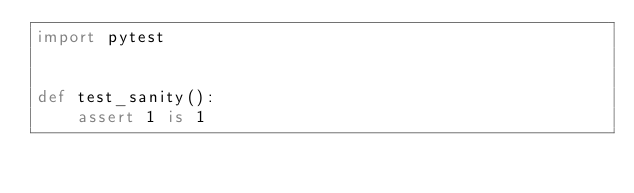Convert code to text. <code><loc_0><loc_0><loc_500><loc_500><_Python_>import pytest


def test_sanity():
    assert 1 is 1
</code> 